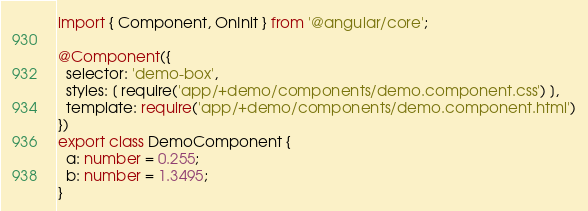Convert code to text. <code><loc_0><loc_0><loc_500><loc_500><_TypeScript_>import { Component, OnInit } from '@angular/core';

@Component({
  selector: 'demo-box',
  styles: [ require('app/+demo/components/demo.component.css') ],
  template: require('app/+demo/components/demo.component.html')
})
export class DemoComponent {
  a: number = 0.255;
  b: number = 1.3495;
}


</code> 